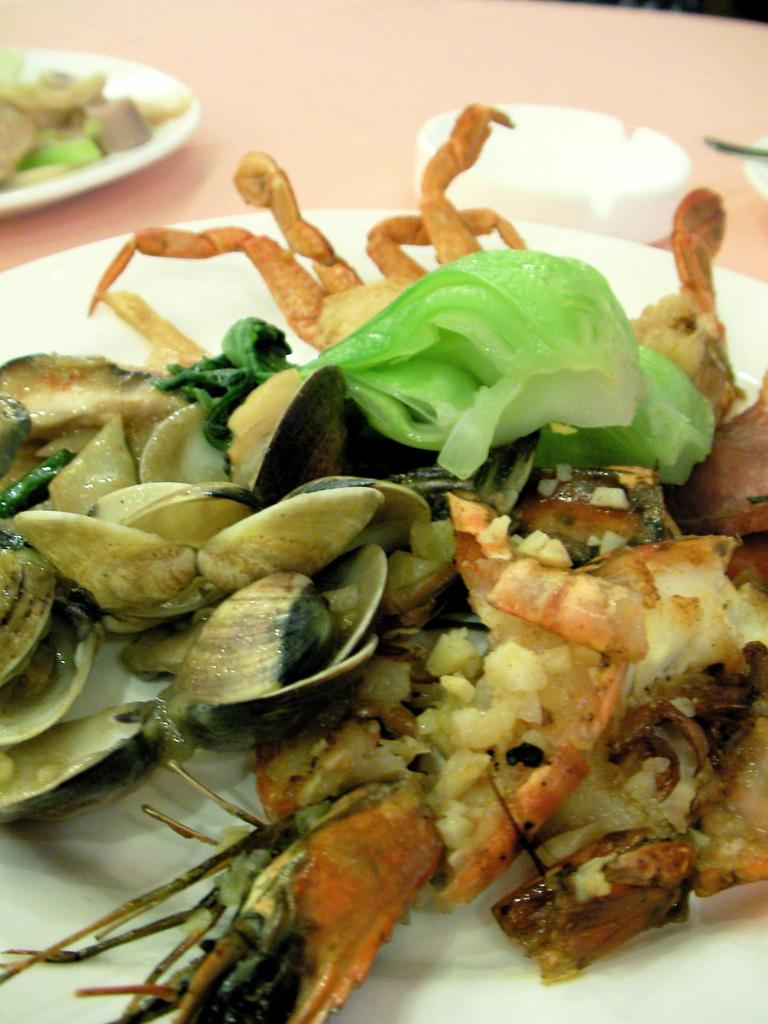What type of food can be seen in the image? There is food in the image, but the specific type of food is not mentioned. How is the food arranged in the image? The food is in a couple of plates and a bowl in the image. What utensil is present in the image? There is a spoon in the image. Where are all these items located? All of these items, including the food, plates, bowl, and spoon, are on a table in the image. What type of mountain can be seen in the background of the image? There is no mountain present in the image. What invention is being used to prepare the food in the image? There is no specific invention mentioned or visible in the image. 